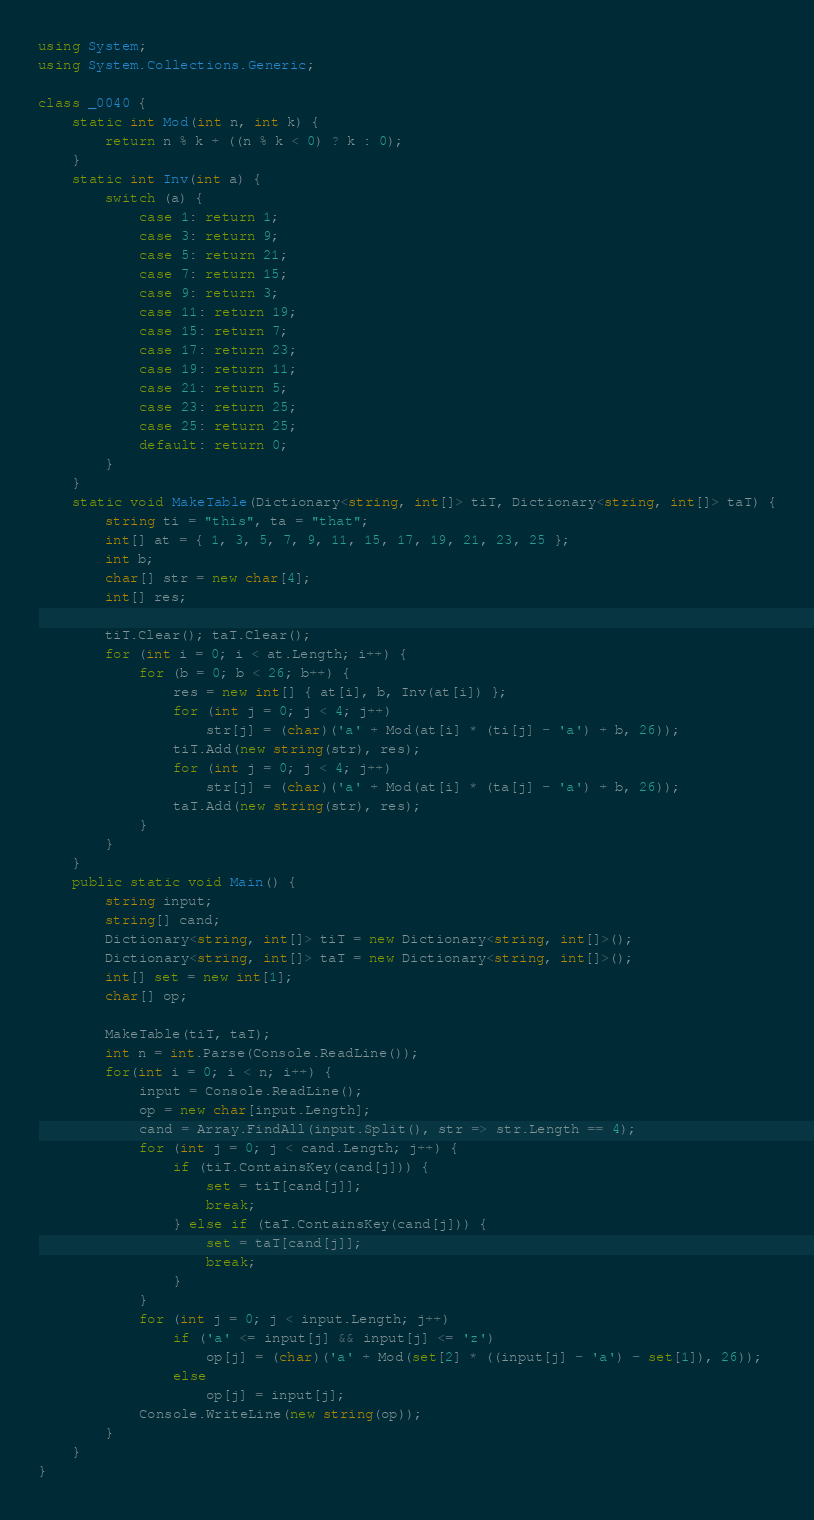Convert code to text. <code><loc_0><loc_0><loc_500><loc_500><_C#_>using System;
using System.Collections.Generic;

class _0040 {
    static int Mod(int n, int k) {
        return n % k + ((n % k < 0) ? k : 0);
    }
    static int Inv(int a) {
        switch (a) {
            case 1: return 1;
            case 3: return 9;
            case 5: return 21;
            case 7: return 15;
            case 9: return 3;
            case 11: return 19;
            case 15: return 7;
            case 17: return 23;
            case 19: return 11;
            case 21: return 5;
            case 23: return 25;
            case 25: return 25;
            default: return 0;
        }
    }
    static void MakeTable(Dictionary<string, int[]> tiT, Dictionary<string, int[]> taT) {
        string ti = "this", ta = "that";
        int[] at = { 1, 3, 5, 7, 9, 11, 15, 17, 19, 21, 23, 25 };
        int b;
        char[] str = new char[4];
        int[] res;

        tiT.Clear(); taT.Clear();
        for (int i = 0; i < at.Length; i++) {
            for (b = 0; b < 26; b++) {
                res = new int[] { at[i], b, Inv(at[i]) };
                for (int j = 0; j < 4; j++)
                    str[j] = (char)('a' + Mod(at[i] * (ti[j] - 'a') + b, 26));
                tiT.Add(new string(str), res);
                for (int j = 0; j < 4; j++)
                    str[j] = (char)('a' + Mod(at[i] * (ta[j] - 'a') + b, 26));
                taT.Add(new string(str), res);
            }
        }
    }  
    public static void Main() {
        string input;
        string[] cand;
        Dictionary<string, int[]> tiT = new Dictionary<string, int[]>();
        Dictionary<string, int[]> taT = new Dictionary<string, int[]>();
        int[] set = new int[1];
        char[] op;

        MakeTable(tiT, taT);
        int n = int.Parse(Console.ReadLine());
        for(int i = 0; i < n; i++) {
            input = Console.ReadLine();
            op = new char[input.Length];
            cand = Array.FindAll(input.Split(), str => str.Length == 4);
            for (int j = 0; j < cand.Length; j++) {
                if (tiT.ContainsKey(cand[j])) {
                    set = tiT[cand[j]];
                    break;
                } else if (taT.ContainsKey(cand[j])) {
                    set = taT[cand[j]];
                    break;
                }
            }
            for (int j = 0; j < input.Length; j++)
                if ('a' <= input[j] && input[j] <= 'z')
                    op[j] = (char)('a' + Mod(set[2] * ((input[j] - 'a') - set[1]), 26));
                else
                    op[j] = input[j];
            Console.WriteLine(new string(op));
        }
    }
}</code> 